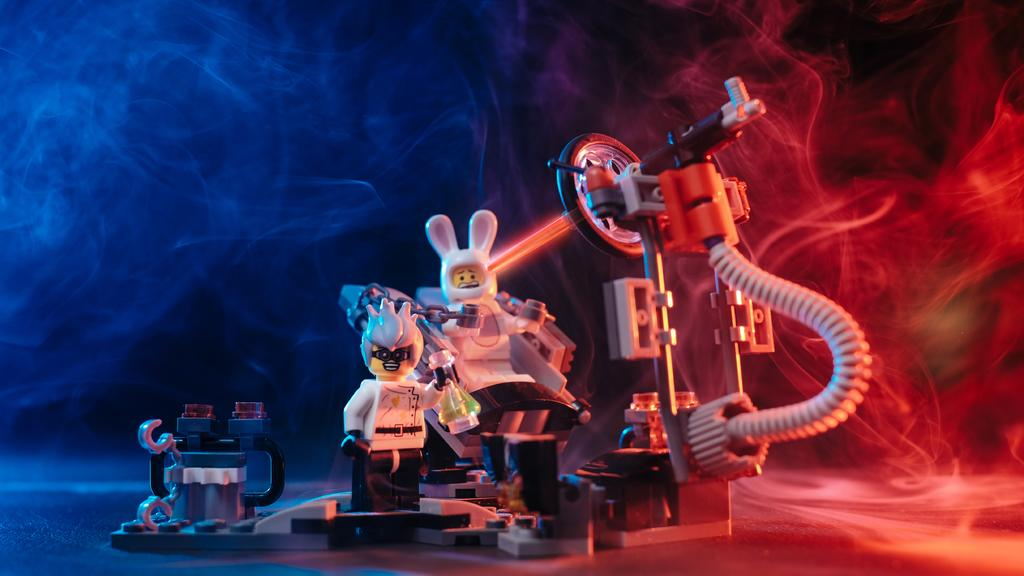What objects can be seen in the image? There are toys in the image. Can you describe anything else that is visible in the image? Yes, there is smoke visible in the image. Is there a stream of water flowing through the toys in the image? No, there is no stream of water visible in the image. 